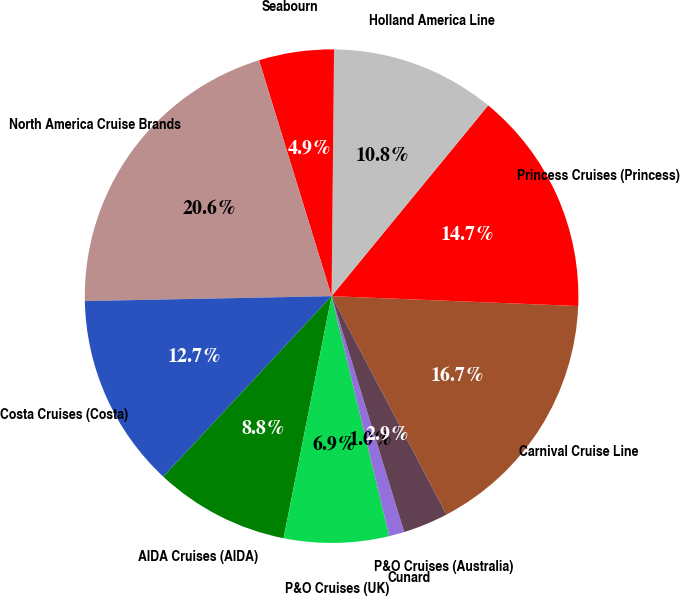Convert chart. <chart><loc_0><loc_0><loc_500><loc_500><pie_chart><fcel>Carnival Cruise Line<fcel>Princess Cruises (Princess)<fcel>Holland America Line<fcel>Seabourn<fcel>North America Cruise Brands<fcel>Costa Cruises (Costa)<fcel>AIDA Cruises (AIDA)<fcel>P&O Cruises (UK)<fcel>Cunard<fcel>P&O Cruises (Australia)<nl><fcel>16.66%<fcel>14.7%<fcel>10.78%<fcel>4.91%<fcel>20.57%<fcel>12.74%<fcel>8.83%<fcel>6.87%<fcel>1.0%<fcel>2.95%<nl></chart> 